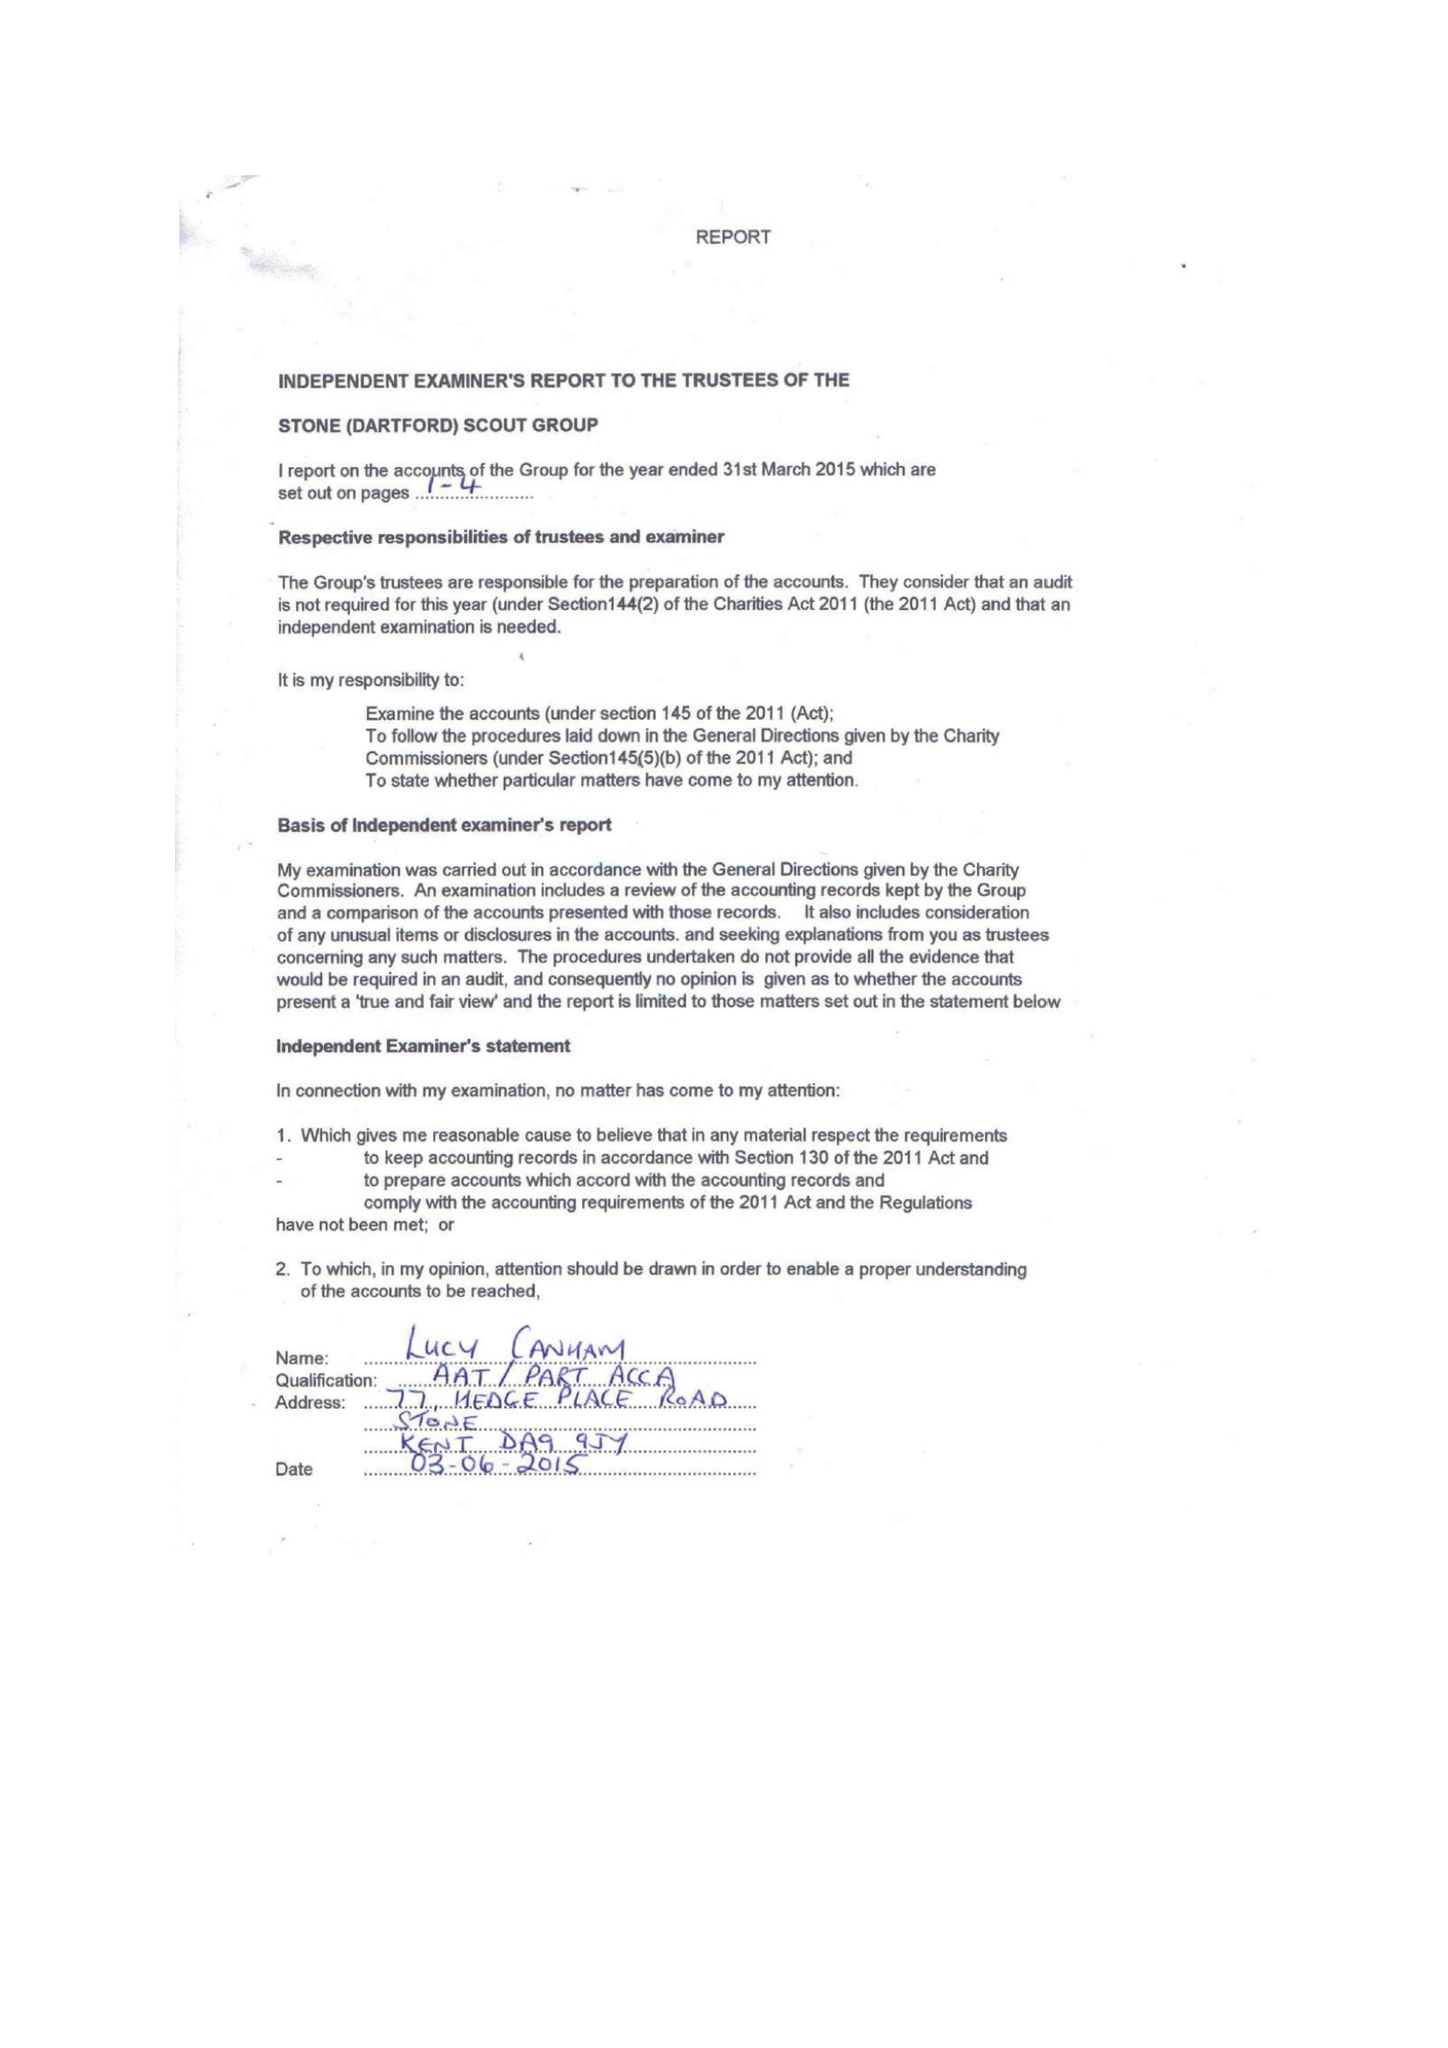What is the value for the charity_name?
Answer the question using a single word or phrase. Stone Scout Group 